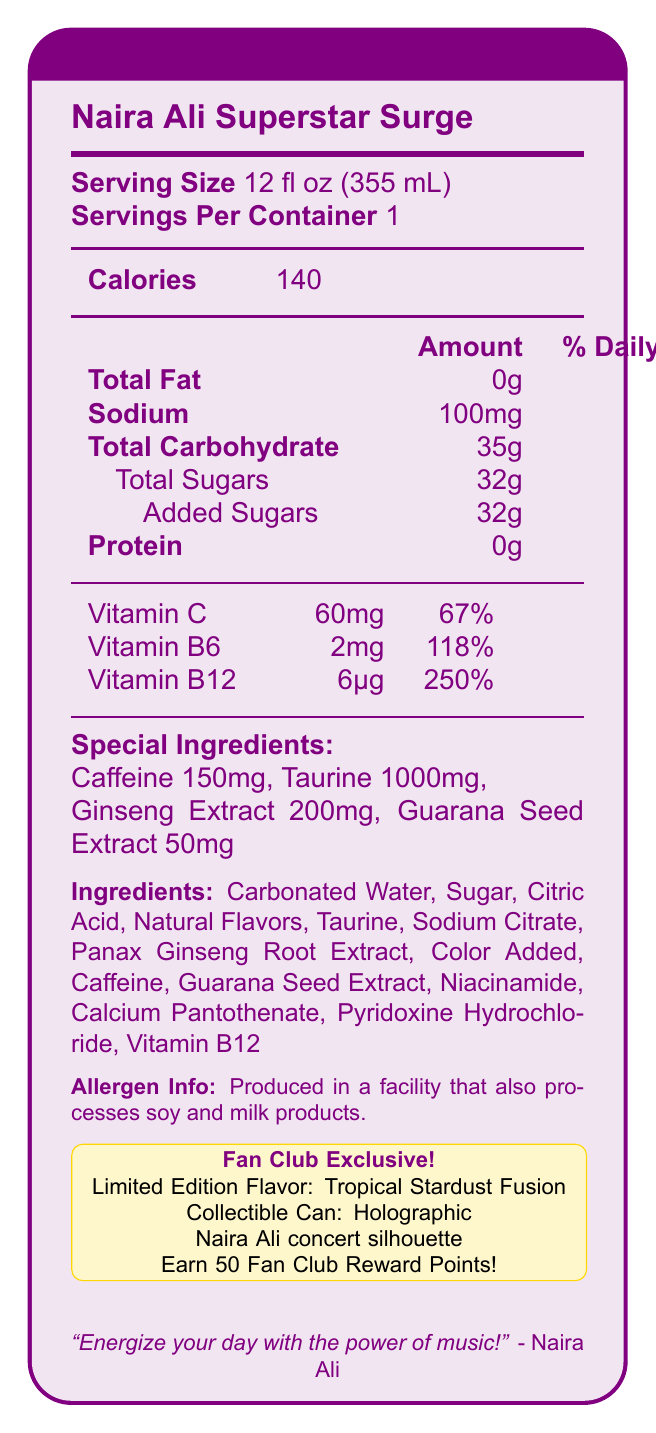what is the serving size of Naira Ali Superstar Surge? The serving size is clearly mentioned as 12 fl oz (355 mL) in the document.
Answer: 12 fl oz (355 mL) how many calories are in one serving of the drink? The document specifies that there are 140 calories per serving.
Answer: 140 how many grams of total sugar does the drink contain? According to the document, the amount of total sugars in the drink is 32g.
Answer: 32g what is the percentage of daily value for Vitamin B12? The document states that the daily value percentage for Vitamin B12 is 250%.
Answer: 250% list the four special ingredients in the drink. The special ingredients are listed as Caffeine (150mg), Taurine (1000mg), Ginseng Extract (200mg), and Guarana Seed Extract (50mg).
Answer: Caffeine, Taurine, Ginseng Extract, Guarana Seed Extract which of the following ingredients is not in the drink? 
A. Carbonated Water 
B. High Fructose Corn Syrup 
C. Citric Acid The document lists Carbonated Water and Citric Acid among the ingredients but does not mention High Fructose Corn Syrup.
Answer: B what is the limited edition flavor called? 
I. Blazing Berry Burst 
II. Tropical Stardust Fusion 
III. Galactic Vanilla Dream The document specifies that the limited edition flavor is called "Tropical Stardust Fusion."
Answer: II is the product suitable for someone with a soy allergy? The allergen information states that the product is produced in a facility that also processes soy, which may not be suitable for someone with a soy allergy.
Answer: No summarize the main features of the Naira Ali-themed energy drink. The document provides detailed nutrition facts, ingredient information, and exclusive features of the Naira Ali-themed energy drink, including its unique flavor and collectible design.
Answer: The Naira Ali Superstar Surge is a fan club exclusive, limited edition energy drink with a Tropical Stardust Fusion flavor. It contains 140 calories, 32g of sugars, 150mg of caffeine, and special ingredients like Taurine, Ginseng Extract, and Guarana Seed Extract. It also provides high daily values of Vitamin C, Vitamin B6, and Vitamin B12. The collectible can has a holographic Naira Ali concert silhouette design, and purchasing it earns 50 Fan Club Reward Points. how many reward points do you earn by purchasing this drink? The document states that purchasing the drink earns you 50 Fan Club Reward Points.
Answer: 50 how much sodium is in the drink? The document indicates that the drink contains 100mg of sodium.
Answer: 100mg how many servings are in one container of the drink? The document explicitly states that there is 1 serving per container.
Answer: 1 what does the Naira Ali quote on the can say? The document includes the quote from Naira Ali, which says, "Energize your day with the power of music!"
Answer: "Energize your day with the power of music!" can you determine the manufacturer of the energy drink based on the document? The document does not provide any information regarding the manufacturer of the energy drink.
Answer: Cannot be determined 